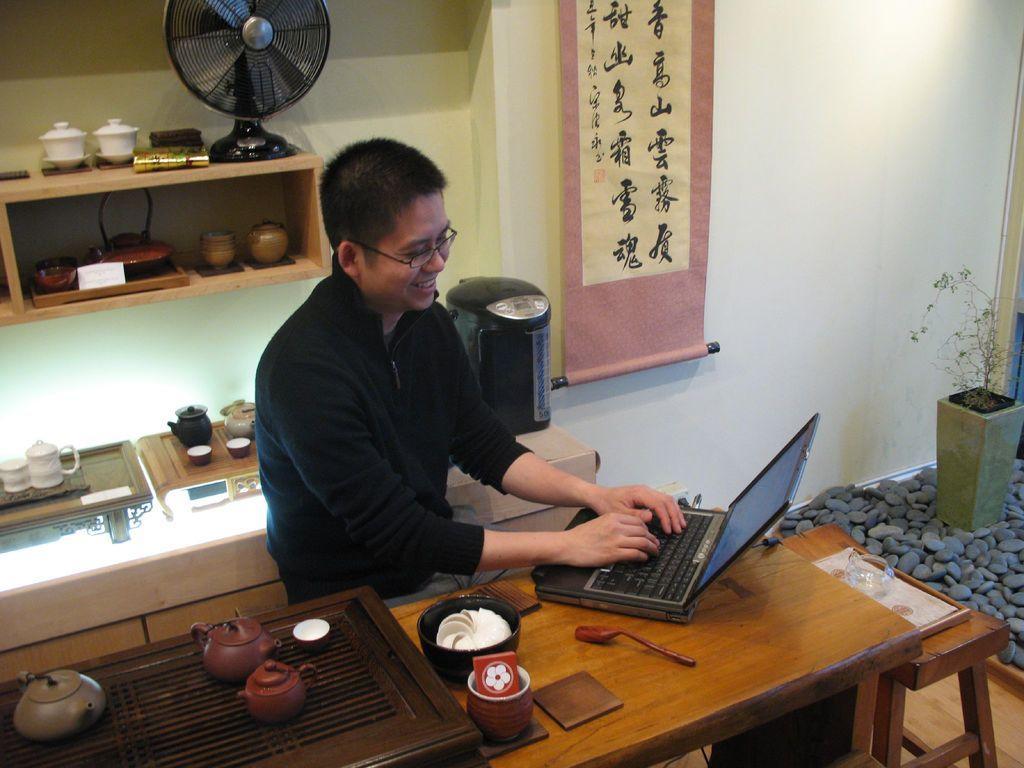Could you give a brief overview of what you see in this image? In the center of the image there is a man sitting before him. There is a table we can see a laptop, bowl, teapots, cup and a spoon placed on the table. On the right side there are stones and a plant placed between the stones. In the background there is a flag and shelves. we can also see fans, pots and some cups placed in the shelves. 